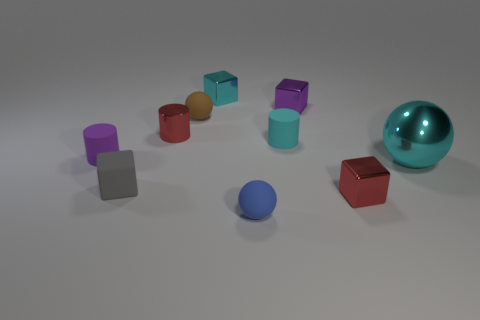How many other objects are the same color as the metallic cylinder?
Give a very brief answer. 1. Is the number of things that are behind the big cyan metallic object less than the number of large balls?
Provide a short and direct response. No. There is a small sphere behind the cyan shiny thing that is in front of the cyan metallic object behind the big cyan shiny object; what is its color?
Offer a very short reply. Brown. What size is the red metal object that is the same shape as the small gray object?
Give a very brief answer. Small. Is the number of gray objects that are behind the purple matte thing less than the number of gray cubes that are right of the tiny red shiny block?
Ensure brevity in your answer.  No. What shape is the metallic thing that is on the left side of the small cyan matte object and to the right of the red shiny cylinder?
Make the answer very short. Cube. The cyan thing that is made of the same material as the blue object is what size?
Make the answer very short. Small. Does the small metal cylinder have the same color as the object that is in front of the red metal cube?
Your response must be concise. No. There is a tiny cube that is on the right side of the shiny cylinder and in front of the small shiny cylinder; what material is it?
Your answer should be compact. Metal. What is the size of the rubber thing that is the same color as the big metallic object?
Give a very brief answer. Small. 